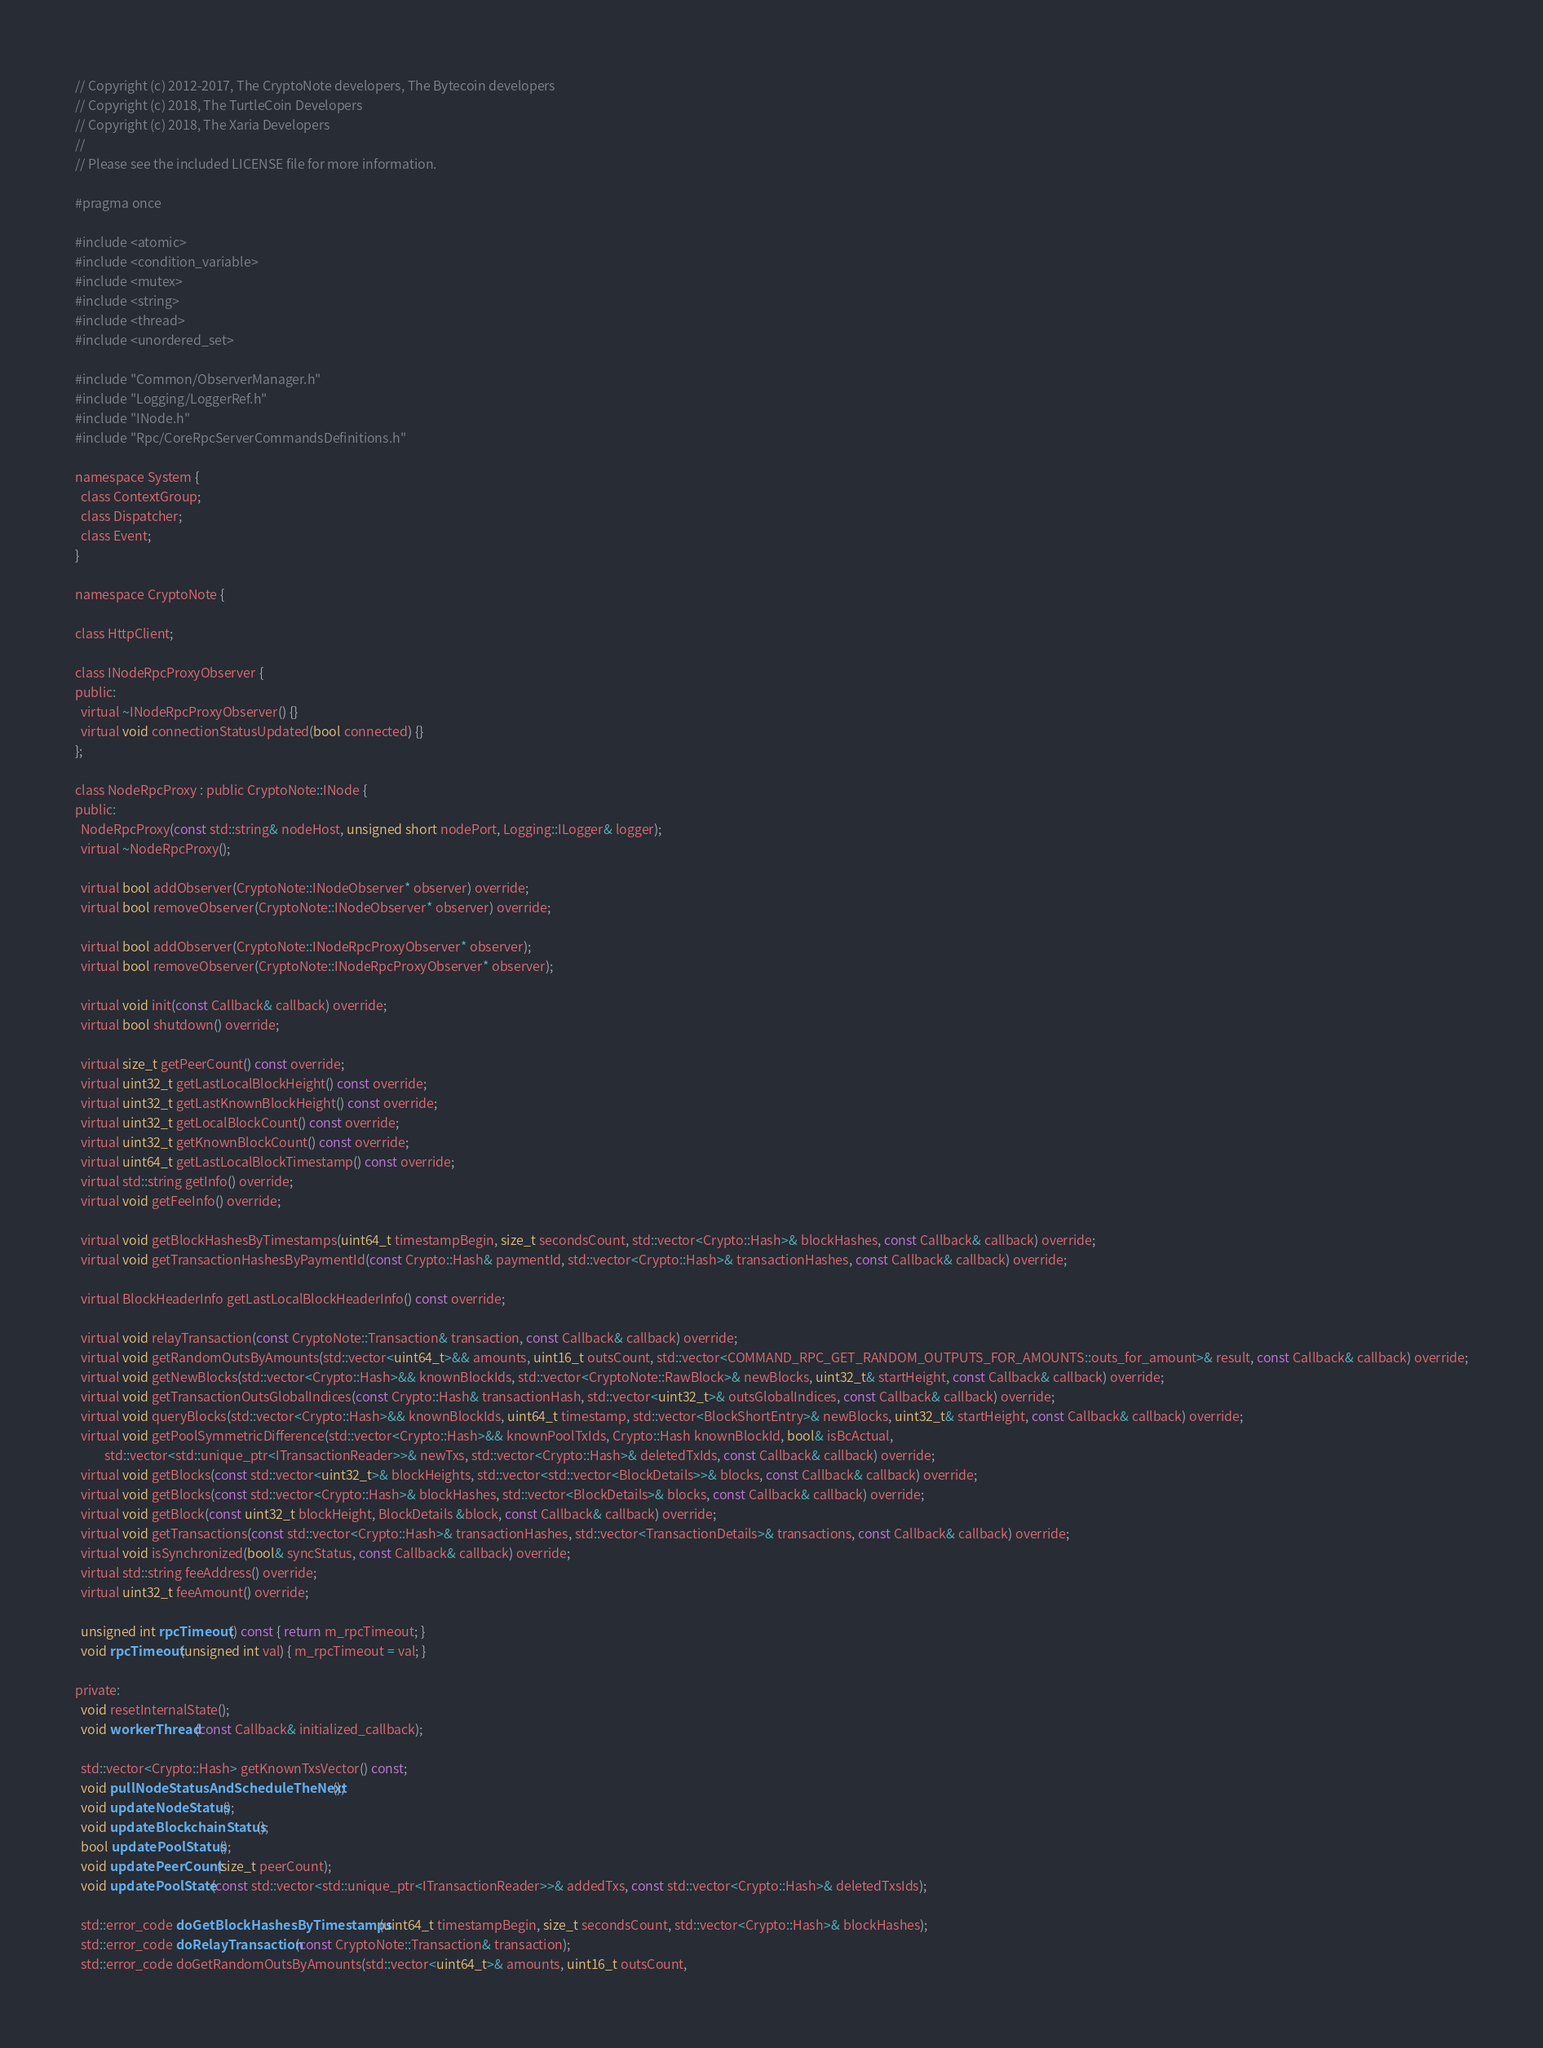Convert code to text. <code><loc_0><loc_0><loc_500><loc_500><_C_>// Copyright (c) 2012-2017, The CryptoNote developers, The Bytecoin developers
// Copyright (c) 2018, The TurtleCoin Developers
// Copyright (c) 2018, The Xaria Developers
// 
// Please see the included LICENSE file for more information.

#pragma once

#include <atomic>
#include <condition_variable>
#include <mutex>
#include <string>
#include <thread>
#include <unordered_set>

#include "Common/ObserverManager.h"
#include "Logging/LoggerRef.h"
#include "INode.h"
#include "Rpc/CoreRpcServerCommandsDefinitions.h"

namespace System {
  class ContextGroup;
  class Dispatcher;
  class Event;
}

namespace CryptoNote {

class HttpClient;

class INodeRpcProxyObserver {
public:
  virtual ~INodeRpcProxyObserver() {}
  virtual void connectionStatusUpdated(bool connected) {}
};

class NodeRpcProxy : public CryptoNote::INode {
public:
  NodeRpcProxy(const std::string& nodeHost, unsigned short nodePort, Logging::ILogger& logger);
  virtual ~NodeRpcProxy();

  virtual bool addObserver(CryptoNote::INodeObserver* observer) override;
  virtual bool removeObserver(CryptoNote::INodeObserver* observer) override;

  virtual bool addObserver(CryptoNote::INodeRpcProxyObserver* observer);
  virtual bool removeObserver(CryptoNote::INodeRpcProxyObserver* observer);

  virtual void init(const Callback& callback) override;
  virtual bool shutdown() override;

  virtual size_t getPeerCount() const override;
  virtual uint32_t getLastLocalBlockHeight() const override;
  virtual uint32_t getLastKnownBlockHeight() const override;
  virtual uint32_t getLocalBlockCount() const override;
  virtual uint32_t getKnownBlockCount() const override;
  virtual uint64_t getLastLocalBlockTimestamp() const override;
  virtual std::string getInfo() override;
  virtual void getFeeInfo() override;

  virtual void getBlockHashesByTimestamps(uint64_t timestampBegin, size_t secondsCount, std::vector<Crypto::Hash>& blockHashes, const Callback& callback) override;
  virtual void getTransactionHashesByPaymentId(const Crypto::Hash& paymentId, std::vector<Crypto::Hash>& transactionHashes, const Callback& callback) override;

  virtual BlockHeaderInfo getLastLocalBlockHeaderInfo() const override;

  virtual void relayTransaction(const CryptoNote::Transaction& transaction, const Callback& callback) override;
  virtual void getRandomOutsByAmounts(std::vector<uint64_t>&& amounts, uint16_t outsCount, std::vector<COMMAND_RPC_GET_RANDOM_OUTPUTS_FOR_AMOUNTS::outs_for_amount>& result, const Callback& callback) override;
  virtual void getNewBlocks(std::vector<Crypto::Hash>&& knownBlockIds, std::vector<CryptoNote::RawBlock>& newBlocks, uint32_t& startHeight, const Callback& callback) override;
  virtual void getTransactionOutsGlobalIndices(const Crypto::Hash& transactionHash, std::vector<uint32_t>& outsGlobalIndices, const Callback& callback) override;
  virtual void queryBlocks(std::vector<Crypto::Hash>&& knownBlockIds, uint64_t timestamp, std::vector<BlockShortEntry>& newBlocks, uint32_t& startHeight, const Callback& callback) override;
  virtual void getPoolSymmetricDifference(std::vector<Crypto::Hash>&& knownPoolTxIds, Crypto::Hash knownBlockId, bool& isBcActual,
          std::vector<std::unique_ptr<ITransactionReader>>& newTxs, std::vector<Crypto::Hash>& deletedTxIds, const Callback& callback) override;
  virtual void getBlocks(const std::vector<uint32_t>& blockHeights, std::vector<std::vector<BlockDetails>>& blocks, const Callback& callback) override;
  virtual void getBlocks(const std::vector<Crypto::Hash>& blockHashes, std::vector<BlockDetails>& blocks, const Callback& callback) override;
  virtual void getBlock(const uint32_t blockHeight, BlockDetails &block, const Callback& callback) override;
  virtual void getTransactions(const std::vector<Crypto::Hash>& transactionHashes, std::vector<TransactionDetails>& transactions, const Callback& callback) override;
  virtual void isSynchronized(bool& syncStatus, const Callback& callback) override;
  virtual std::string feeAddress() override;
  virtual uint32_t feeAmount() override;
  
  unsigned int rpcTimeout() const { return m_rpcTimeout; }
  void rpcTimeout(unsigned int val) { m_rpcTimeout = val; }

private:
  void resetInternalState();
  void workerThread(const Callback& initialized_callback);

  std::vector<Crypto::Hash> getKnownTxsVector() const;
  void pullNodeStatusAndScheduleTheNext();
  void updateNodeStatus();
  void updateBlockchainStatus();
  bool updatePoolStatus();
  void updatePeerCount(size_t peerCount);
  void updatePoolState(const std::vector<std::unique_ptr<ITransactionReader>>& addedTxs, const std::vector<Crypto::Hash>& deletedTxsIds);

  std::error_code doGetBlockHashesByTimestamps(uint64_t timestampBegin, size_t secondsCount, std::vector<Crypto::Hash>& blockHashes);
  std::error_code doRelayTransaction(const CryptoNote::Transaction& transaction);
  std::error_code doGetRandomOutsByAmounts(std::vector<uint64_t>& amounts, uint16_t outsCount,</code> 